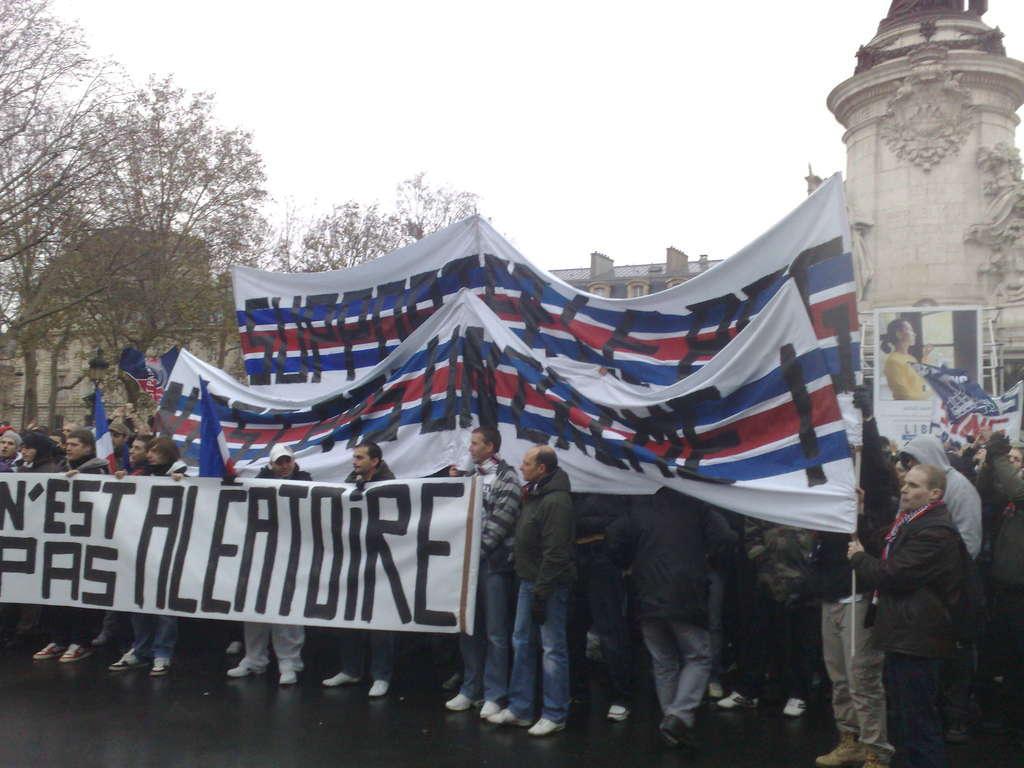Describe this image in one or two sentences. In this image, I can see a group of people standing and holding the banners. In the background, I can see trees, a building and the sky. 